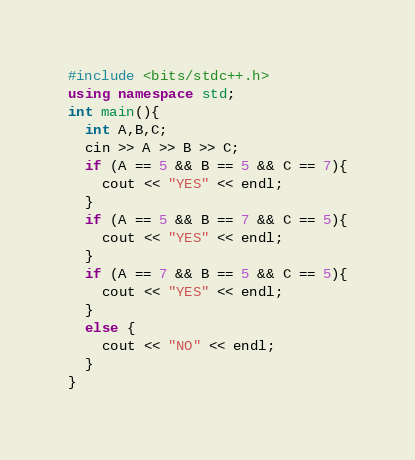<code> <loc_0><loc_0><loc_500><loc_500><_C++_>#include <bits/stdc++.h>
using namespace std;
int main(){
  int A,B,C;
  cin >> A >> B >> C;
  if (A == 5 && B == 5 && C == 7){
    cout << "YES" << endl;
  }
  if (A == 5 && B == 7 && C == 5){
    cout << "YES" << endl;
  }
  if (A == 7 && B == 5 && C == 5){
    cout << "YES" << endl;
  }
  else {
    cout << "NO" << endl;
  }
}</code> 